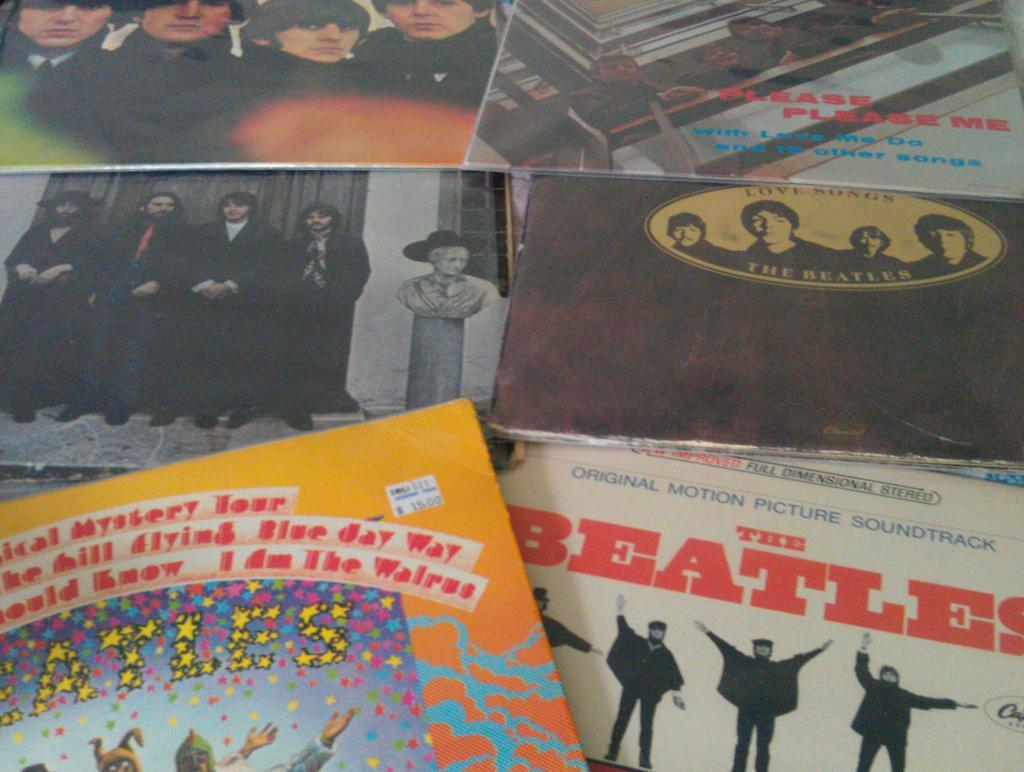What is the bands name?
Make the answer very short. The beatles. The band name is the beatles?
Offer a very short reply. Yes. 